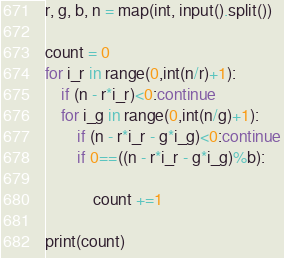<code> <loc_0><loc_0><loc_500><loc_500><_Python_>r, g, b, n = map(int, input().split())
 
count = 0
for i_r in range(0,int(n/r)+1):
    if (n - r*i_r)<0:continue
    for i_g in range(0,int(n/g)+1):
        if (n - r*i_r - g*i_g)<0:continue
        if 0==((n - r*i_r - g*i_g)%b):
 
            count +=1
 
print(count)</code> 